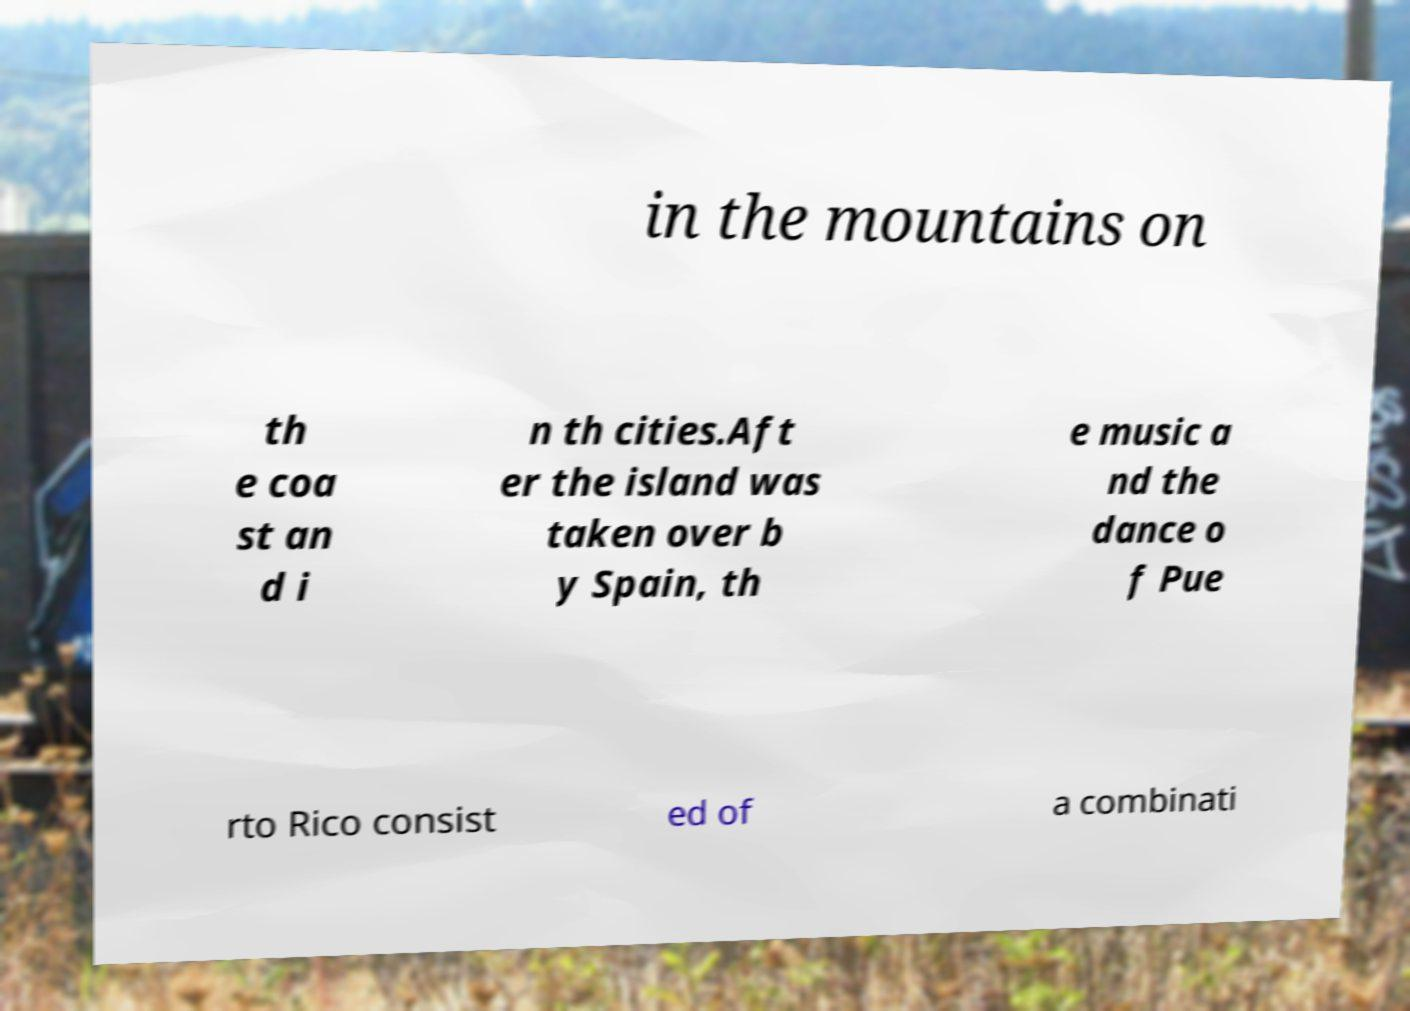Can you read and provide the text displayed in the image?This photo seems to have some interesting text. Can you extract and type it out for me? in the mountains on th e coa st an d i n th cities.Aft er the island was taken over b y Spain, th e music a nd the dance o f Pue rto Rico consist ed of a combinati 